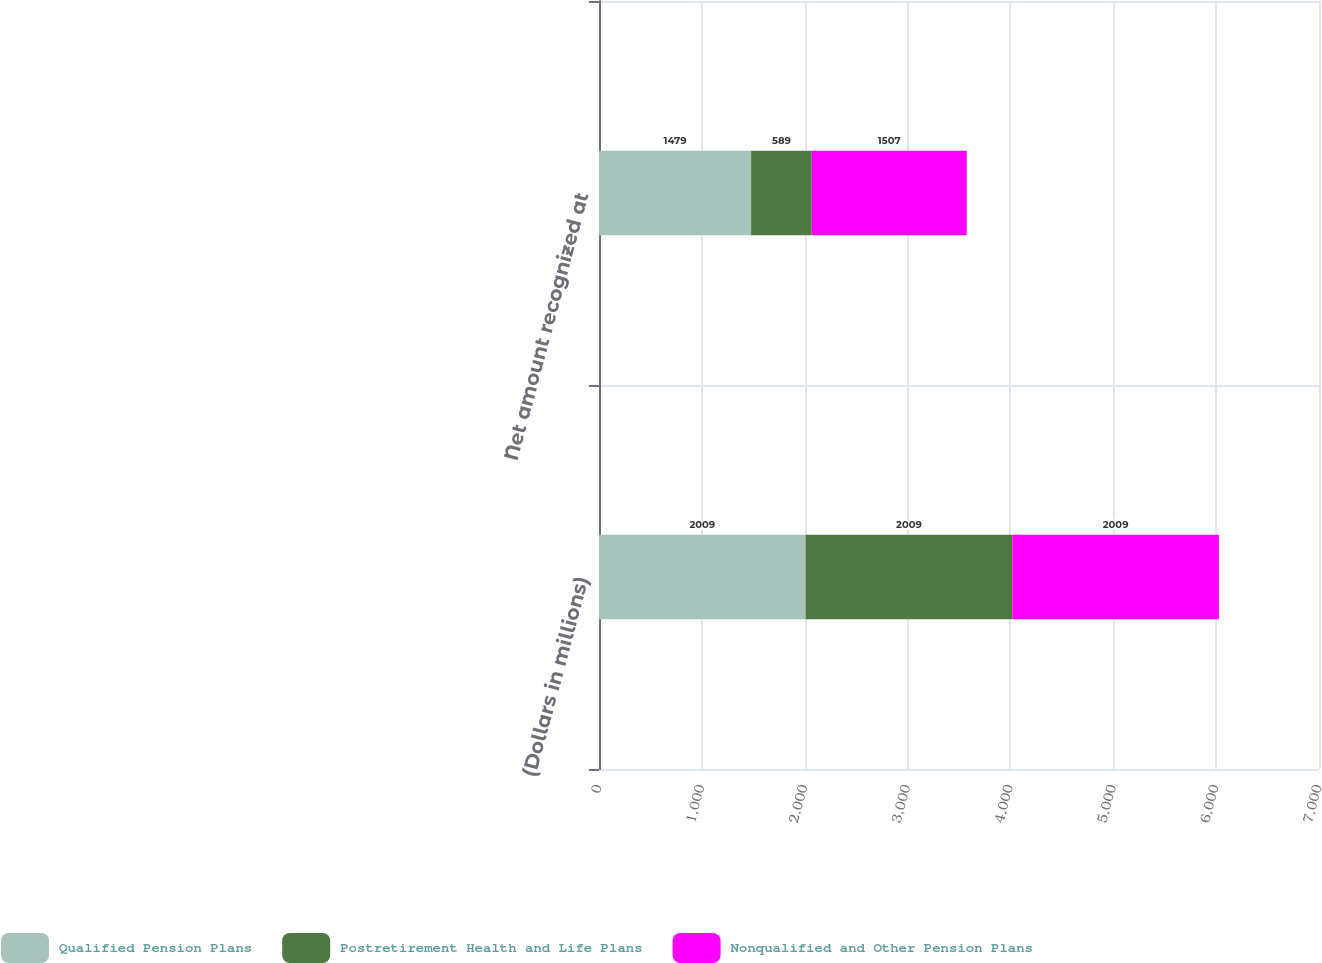Convert chart to OTSL. <chart><loc_0><loc_0><loc_500><loc_500><stacked_bar_chart><ecel><fcel>(Dollars in millions)<fcel>Net amount recognized at<nl><fcel>Qualified Pension Plans<fcel>2009<fcel>1479<nl><fcel>Postretirement Health and Life Plans<fcel>2009<fcel>589<nl><fcel>Nonqualified and Other Pension Plans<fcel>2009<fcel>1507<nl></chart> 